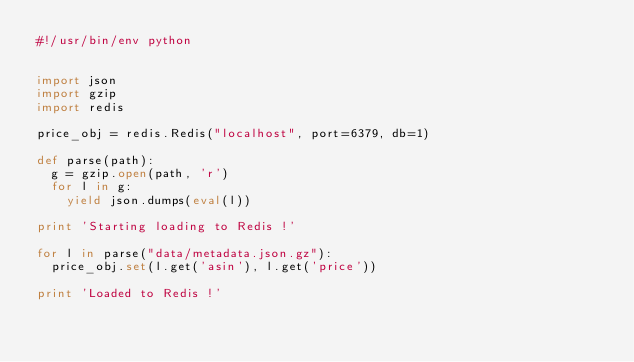<code> <loc_0><loc_0><loc_500><loc_500><_Python_>#!/usr/bin/env python


import json
import gzip
import redis

price_obj = redis.Redis("localhost", port=6379, db=1)

def parse(path):
  g = gzip.open(path, 'r')
  for l in g:
    yield json.dumps(eval(l))

print 'Starting loading to Redis !'

for l in parse("data/metadata.json.gz"):
  price_obj.set(l.get('asin'), l.get('price'))

print 'Loaded to Redis !'</code> 